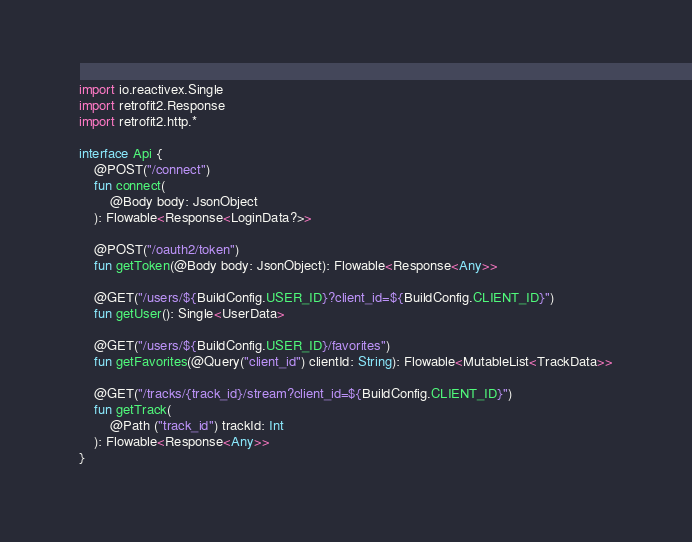Convert code to text. <code><loc_0><loc_0><loc_500><loc_500><_Kotlin_>import io.reactivex.Single
import retrofit2.Response
import retrofit2.http.*

interface Api {
    @POST("/connect")
    fun connect(
        @Body body: JsonObject
    ): Flowable<Response<LoginData?>>

    @POST("/oauth2/token")
    fun getToken(@Body body: JsonObject): Flowable<Response<Any>>

    @GET("/users/${BuildConfig.USER_ID}?client_id=${BuildConfig.CLIENT_ID}")
    fun getUser(): Single<UserData>

    @GET("/users/${BuildConfig.USER_ID}/favorites")
    fun getFavorites(@Query("client_id") clientId: String): Flowable<MutableList<TrackData>>

    @GET("/tracks/{track_id}/stream?client_id=${BuildConfig.CLIENT_ID}")
    fun getTrack(
        @Path ("track_id") trackId: Int
    ): Flowable<Response<Any>>
}
</code> 